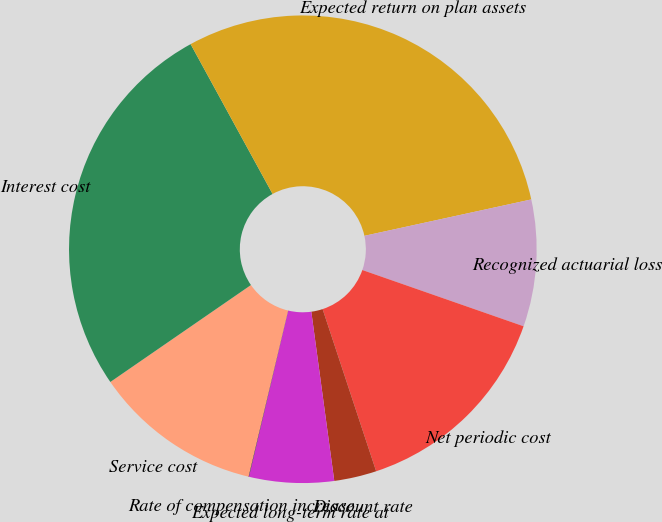Convert chart to OTSL. <chart><loc_0><loc_0><loc_500><loc_500><pie_chart><fcel>Service cost<fcel>Interest cost<fcel>Expected return on plan assets<fcel>Recognized actuarial loss<fcel>Net periodic cost<fcel>Discount rate<fcel>Expected long-term rate at<fcel>Rate of compensation increase<nl><fcel>11.67%<fcel>26.64%<fcel>29.55%<fcel>8.76%<fcel>14.58%<fcel>2.93%<fcel>5.85%<fcel>0.02%<nl></chart> 